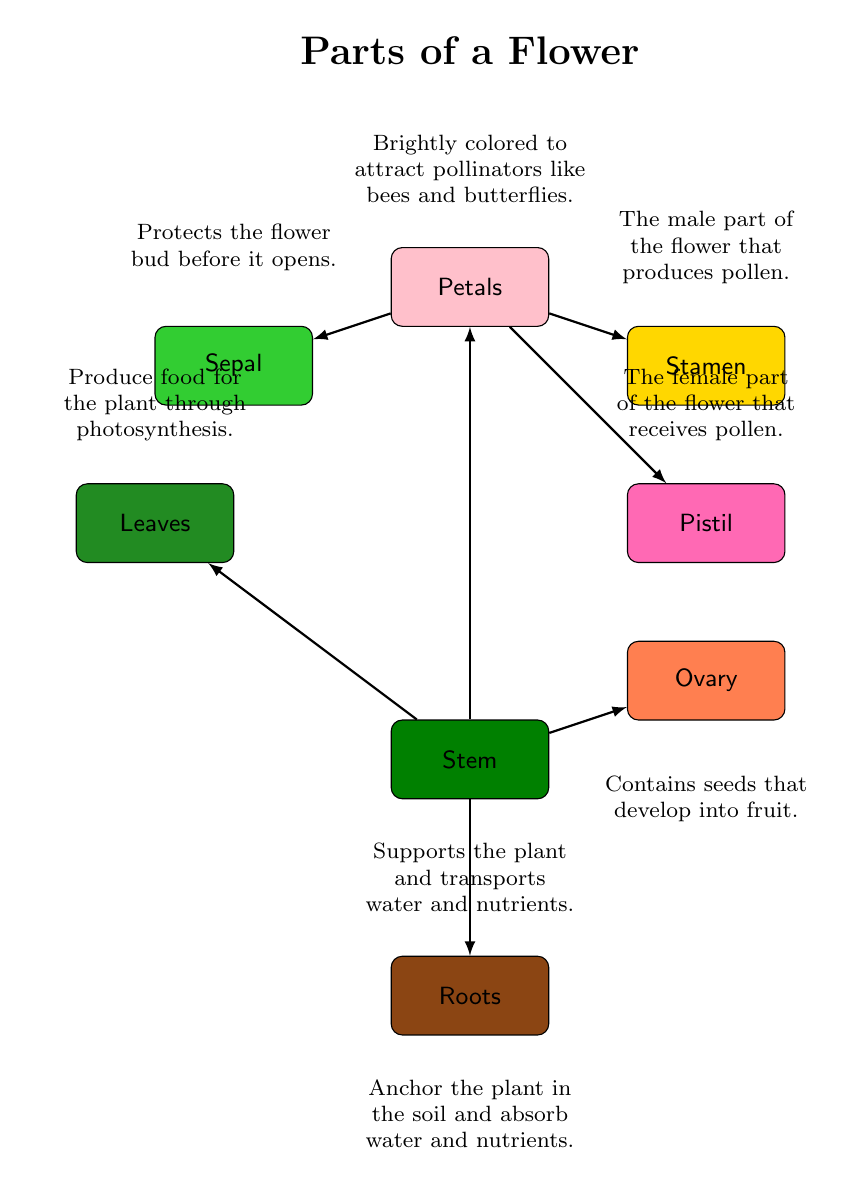What part of the flower is brightly colored to attract pollinators? The diagram labels the bright part of the flower as "Petals," and its description states that they are bright and attract pollinators.
Answer: Petals What part supports the plant and transports water and nutrients? The diagram indicates that the part described as "Stem" is responsible for this function, based on the accompanying description.
Answer: Stem How many main parts of a flower are labeled in the diagram? By counting the labeled parts shown in the diagram (including petals, stem, leaves, roots, stamen, pistil, sepal, ovary), there are a total of eight parts.
Answer: 8 What is the function of leaves as depicted in the diagram? The diagram describes leaves as parts that "Produce food for the plant through photosynthesis," providing their main function.
Answer: Produce food through photosynthesis Which part contains seeds that develop into fruit? The diagram specifically labels the "Ovary" as the part that contains seeds, and the description confirms this function.
Answer: Ovary What connects the stamen to the petals in the diagram? The diagram shows an arrow indicating a connection from "Petals" to "Stamen," suggesting an anatomical and functional link between the two.
Answer: Petals What part protects the flower bud before it opens? According to the diagram, the "Sepal" is identified as the protective part of the flower bud, as mentioned in its description.
Answer: Sepal Which part is identified as the female part of the flower? The diagram labels the "Pistil" as the female part of the flower, and the description clarifies its role in receiving pollen.
Answer: Pistil What part anchors the plant in the soil? The diagram clearly identifies the "Roots" as the part responsible for anchoring the plant and absorbing water and nutrients, according to its description.
Answer: Roots 